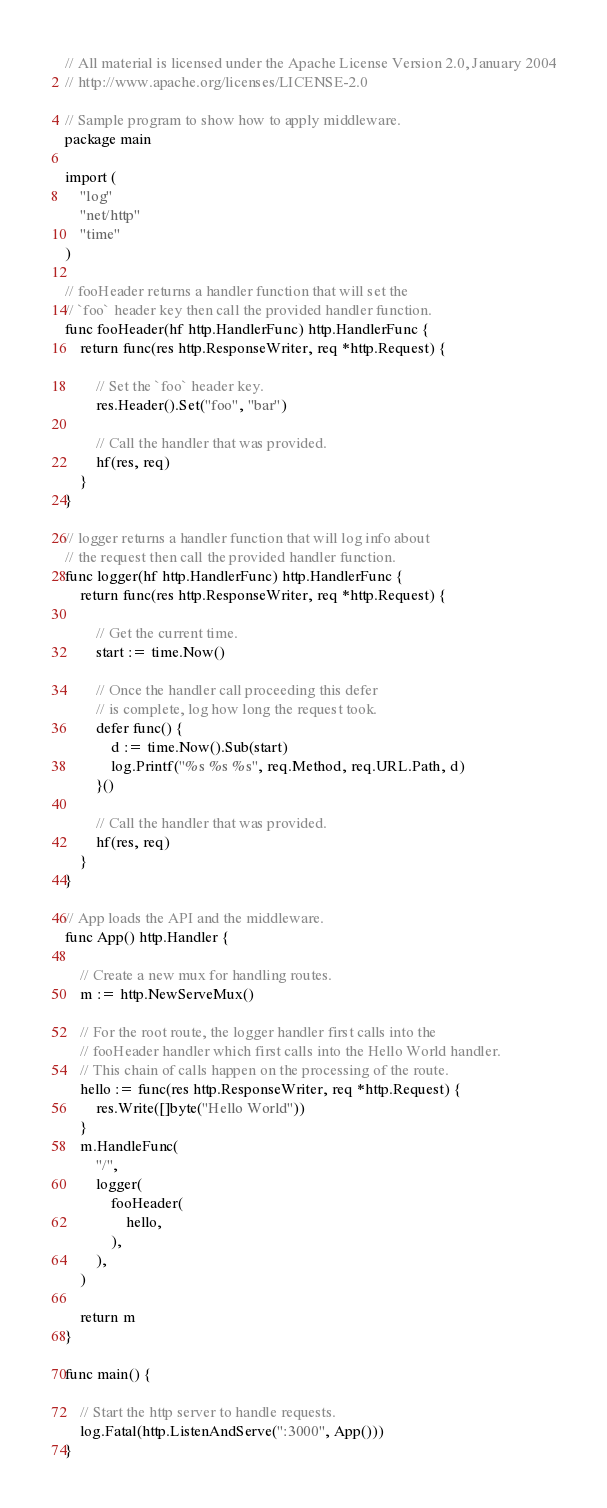<code> <loc_0><loc_0><loc_500><loc_500><_Go_>// All material is licensed under the Apache License Version 2.0, January 2004
// http://www.apache.org/licenses/LICENSE-2.0

// Sample program to show how to apply middleware.
package main

import (
	"log"
	"net/http"
	"time"
)

// fooHeader returns a handler function that will set the
// `foo` header key then call the provided handler function.
func fooHeader(hf http.HandlerFunc) http.HandlerFunc {
	return func(res http.ResponseWriter, req *http.Request) {

		// Set the `foo` header key.
		res.Header().Set("foo", "bar")

		// Call the handler that was provided.
		hf(res, req)
	}
}

// logger returns a handler function that will log info about
// the request then call the provided handler function.
func logger(hf http.HandlerFunc) http.HandlerFunc {
	return func(res http.ResponseWriter, req *http.Request) {

		// Get the current time.
		start := time.Now()

		// Once the handler call proceeding this defer
		// is complete, log how long the request took.
		defer func() {
			d := time.Now().Sub(start)
			log.Printf("%s %s %s", req.Method, req.URL.Path, d)
		}()

		// Call the handler that was provided.
		hf(res, req)
	}
}

// App loads the API and the middleware.
func App() http.Handler {

	// Create a new mux for handling routes.
	m := http.NewServeMux()

	// For the root route, the logger handler first calls into the
	// fooHeader handler which first calls into the Hello World handler.
	// This chain of calls happen on the processing of the route.
	hello := func(res http.ResponseWriter, req *http.Request) {
		res.Write([]byte("Hello World"))
	}
	m.HandleFunc(
		"/",
		logger(
			fooHeader(
				hello,
			),
		),
	)

	return m
}

func main() {

	// Start the http server to handle requests.
	log.Fatal(http.ListenAndServe(":3000", App()))
}
</code> 